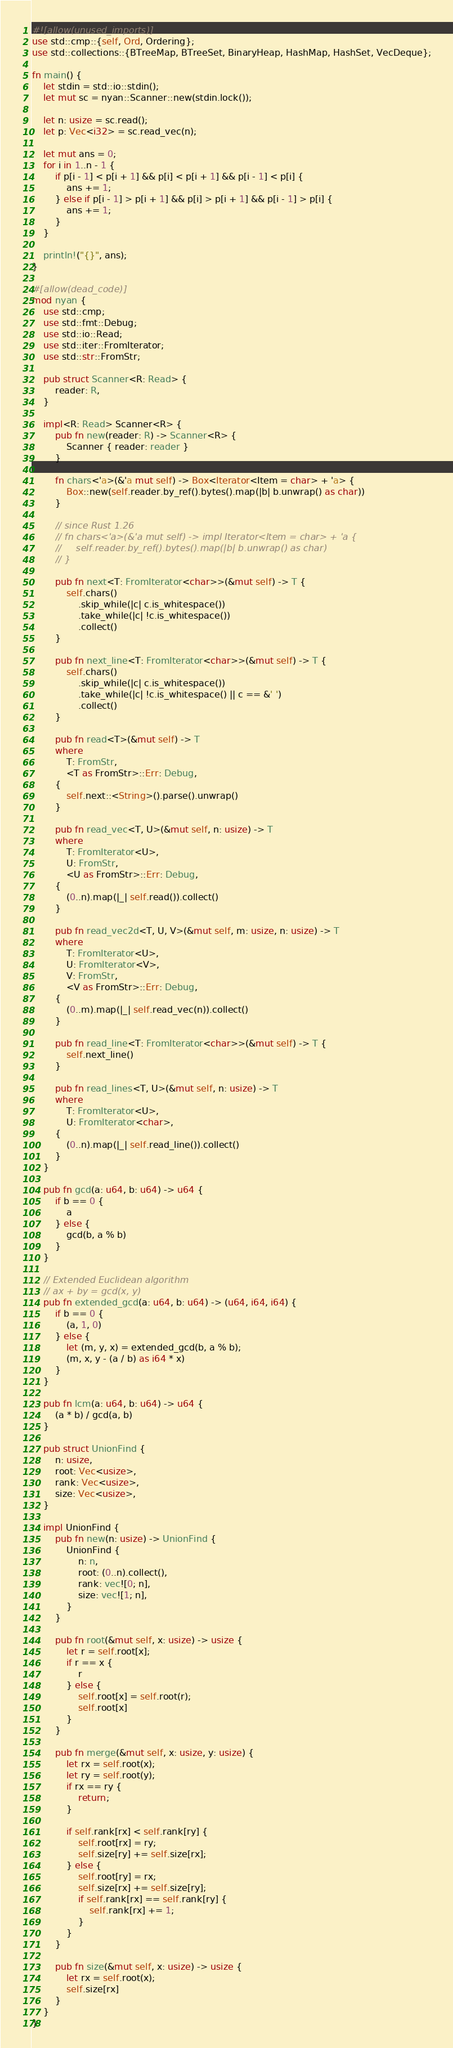Convert code to text. <code><loc_0><loc_0><loc_500><loc_500><_Rust_>#![allow(unused_imports)]
use std::cmp::{self, Ord, Ordering};
use std::collections::{BTreeMap, BTreeSet, BinaryHeap, HashMap, HashSet, VecDeque};

fn main() {
    let stdin = std::io::stdin();
    let mut sc = nyan::Scanner::new(stdin.lock());

    let n: usize = sc.read();
    let p: Vec<i32> = sc.read_vec(n);

    let mut ans = 0;
    for i in 1..n - 1 {
        if p[i - 1] < p[i + 1] && p[i] < p[i + 1] && p[i - 1] < p[i] {
            ans += 1;
        } else if p[i - 1] > p[i + 1] && p[i] > p[i + 1] && p[i - 1] > p[i] {
            ans += 1;
        }
    }

    println!("{}", ans);
}

#[allow(dead_code)]
mod nyan {
    use std::cmp;
    use std::fmt::Debug;
    use std::io::Read;
    use std::iter::FromIterator;
    use std::str::FromStr;

    pub struct Scanner<R: Read> {
        reader: R,
    }

    impl<R: Read> Scanner<R> {
        pub fn new(reader: R) -> Scanner<R> {
            Scanner { reader: reader }
        }

        fn chars<'a>(&'a mut self) -> Box<Iterator<Item = char> + 'a> {
            Box::new(self.reader.by_ref().bytes().map(|b| b.unwrap() as char))
        }

        // since Rust 1.26
        // fn chars<'a>(&'a mut self) -> impl Iterator<Item = char> + 'a {
        //     self.reader.by_ref().bytes().map(|b| b.unwrap() as char)
        // }

        pub fn next<T: FromIterator<char>>(&mut self) -> T {
            self.chars()
                .skip_while(|c| c.is_whitespace())
                .take_while(|c| !c.is_whitespace())
                .collect()
        }

        pub fn next_line<T: FromIterator<char>>(&mut self) -> T {
            self.chars()
                .skip_while(|c| c.is_whitespace())
                .take_while(|c| !c.is_whitespace() || c == &' ')
                .collect()
        }

        pub fn read<T>(&mut self) -> T
        where
            T: FromStr,
            <T as FromStr>::Err: Debug,
        {
            self.next::<String>().parse().unwrap()
        }

        pub fn read_vec<T, U>(&mut self, n: usize) -> T
        where
            T: FromIterator<U>,
            U: FromStr,
            <U as FromStr>::Err: Debug,
        {
            (0..n).map(|_| self.read()).collect()
        }

        pub fn read_vec2d<T, U, V>(&mut self, m: usize, n: usize) -> T
        where
            T: FromIterator<U>,
            U: FromIterator<V>,
            V: FromStr,
            <V as FromStr>::Err: Debug,
        {
            (0..m).map(|_| self.read_vec(n)).collect()
        }

        pub fn read_line<T: FromIterator<char>>(&mut self) -> T {
            self.next_line()
        }

        pub fn read_lines<T, U>(&mut self, n: usize) -> T
        where
            T: FromIterator<U>,
            U: FromIterator<char>,
        {
            (0..n).map(|_| self.read_line()).collect()
        }
    }

    pub fn gcd(a: u64, b: u64) -> u64 {
        if b == 0 {
            a
        } else {
            gcd(b, a % b)
        }
    }

    // Extended Euclidean algorithm
    // ax + by = gcd(x, y)
    pub fn extended_gcd(a: u64, b: u64) -> (u64, i64, i64) {
        if b == 0 {
            (a, 1, 0)
        } else {
            let (m, y, x) = extended_gcd(b, a % b);
            (m, x, y - (a / b) as i64 * x)
        }
    }

    pub fn lcm(a: u64, b: u64) -> u64 {
        (a * b) / gcd(a, b)
    }

    pub struct UnionFind {
        n: usize,
        root: Vec<usize>,
        rank: Vec<usize>,
        size: Vec<usize>,
    }

    impl UnionFind {
        pub fn new(n: usize) -> UnionFind {
            UnionFind {
                n: n,
                root: (0..n).collect(),
                rank: vec![0; n],
                size: vec![1; n],
            }
        }

        pub fn root(&mut self, x: usize) -> usize {
            let r = self.root[x];
            if r == x {
                r
            } else {
                self.root[x] = self.root(r);
                self.root[x]
            }
        }

        pub fn merge(&mut self, x: usize, y: usize) {
            let rx = self.root(x);
            let ry = self.root(y);
            if rx == ry {
                return;
            }

            if self.rank[rx] < self.rank[ry] {
                self.root[rx] = ry;
                self.size[ry] += self.size[rx];
            } else {
                self.root[ry] = rx;
                self.size[rx] += self.size[ry];
                if self.rank[rx] == self.rank[ry] {
                    self.rank[rx] += 1;
                }
            }
        }

        pub fn size(&mut self, x: usize) -> usize {
            let rx = self.root(x);
            self.size[rx]
        }
    }
}
</code> 